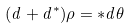Convert formula to latex. <formula><loc_0><loc_0><loc_500><loc_500>( d + d ^ { * } ) \rho = * d \theta</formula> 